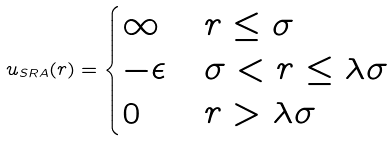Convert formula to latex. <formula><loc_0><loc_0><loc_500><loc_500>u _ { S R A } ( r ) = \begin{cases} \infty & r \leq \sigma \\ - \epsilon & \sigma < r \leq \lambda \sigma \\ 0 & r > \lambda \sigma \\ \end{cases}</formula> 